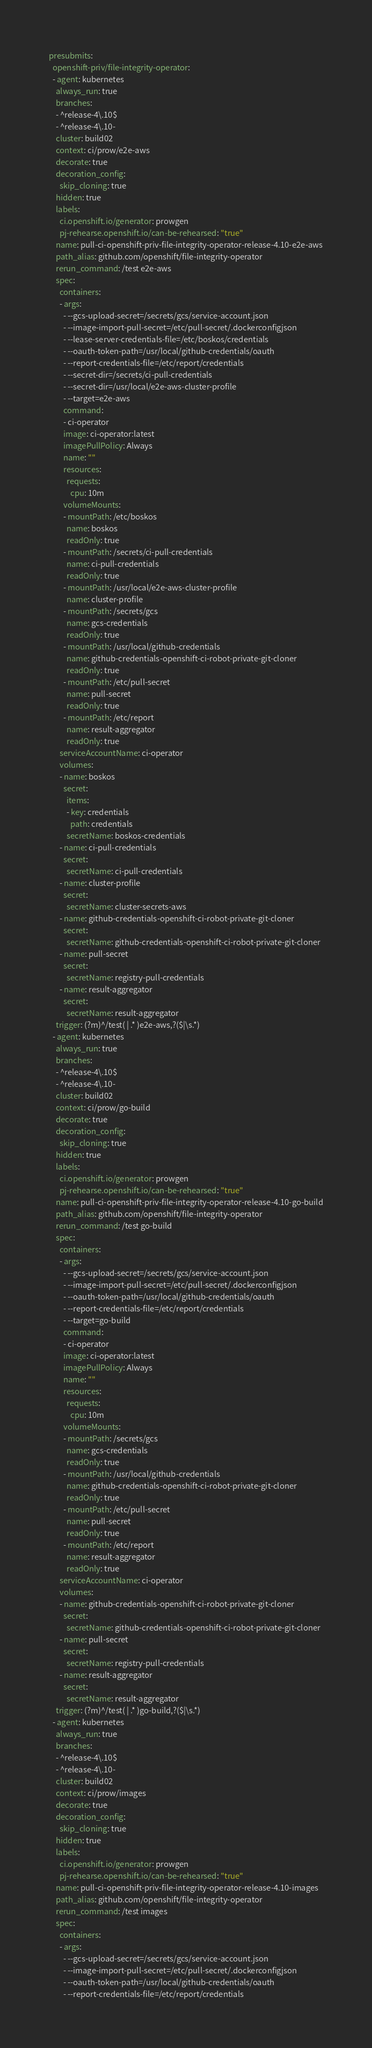Convert code to text. <code><loc_0><loc_0><loc_500><loc_500><_YAML_>presubmits:
  openshift-priv/file-integrity-operator:
  - agent: kubernetes
    always_run: true
    branches:
    - ^release-4\.10$
    - ^release-4\.10-
    cluster: build02
    context: ci/prow/e2e-aws
    decorate: true
    decoration_config:
      skip_cloning: true
    hidden: true
    labels:
      ci.openshift.io/generator: prowgen
      pj-rehearse.openshift.io/can-be-rehearsed: "true"
    name: pull-ci-openshift-priv-file-integrity-operator-release-4.10-e2e-aws
    path_alias: github.com/openshift/file-integrity-operator
    rerun_command: /test e2e-aws
    spec:
      containers:
      - args:
        - --gcs-upload-secret=/secrets/gcs/service-account.json
        - --image-import-pull-secret=/etc/pull-secret/.dockerconfigjson
        - --lease-server-credentials-file=/etc/boskos/credentials
        - --oauth-token-path=/usr/local/github-credentials/oauth
        - --report-credentials-file=/etc/report/credentials
        - --secret-dir=/secrets/ci-pull-credentials
        - --secret-dir=/usr/local/e2e-aws-cluster-profile
        - --target=e2e-aws
        command:
        - ci-operator
        image: ci-operator:latest
        imagePullPolicy: Always
        name: ""
        resources:
          requests:
            cpu: 10m
        volumeMounts:
        - mountPath: /etc/boskos
          name: boskos
          readOnly: true
        - mountPath: /secrets/ci-pull-credentials
          name: ci-pull-credentials
          readOnly: true
        - mountPath: /usr/local/e2e-aws-cluster-profile
          name: cluster-profile
        - mountPath: /secrets/gcs
          name: gcs-credentials
          readOnly: true
        - mountPath: /usr/local/github-credentials
          name: github-credentials-openshift-ci-robot-private-git-cloner
          readOnly: true
        - mountPath: /etc/pull-secret
          name: pull-secret
          readOnly: true
        - mountPath: /etc/report
          name: result-aggregator
          readOnly: true
      serviceAccountName: ci-operator
      volumes:
      - name: boskos
        secret:
          items:
          - key: credentials
            path: credentials
          secretName: boskos-credentials
      - name: ci-pull-credentials
        secret:
          secretName: ci-pull-credentials
      - name: cluster-profile
        secret:
          secretName: cluster-secrets-aws
      - name: github-credentials-openshift-ci-robot-private-git-cloner
        secret:
          secretName: github-credentials-openshift-ci-robot-private-git-cloner
      - name: pull-secret
        secret:
          secretName: registry-pull-credentials
      - name: result-aggregator
        secret:
          secretName: result-aggregator
    trigger: (?m)^/test( | .* )e2e-aws,?($|\s.*)
  - agent: kubernetes
    always_run: true
    branches:
    - ^release-4\.10$
    - ^release-4\.10-
    cluster: build02
    context: ci/prow/go-build
    decorate: true
    decoration_config:
      skip_cloning: true
    hidden: true
    labels:
      ci.openshift.io/generator: prowgen
      pj-rehearse.openshift.io/can-be-rehearsed: "true"
    name: pull-ci-openshift-priv-file-integrity-operator-release-4.10-go-build
    path_alias: github.com/openshift/file-integrity-operator
    rerun_command: /test go-build
    spec:
      containers:
      - args:
        - --gcs-upload-secret=/secrets/gcs/service-account.json
        - --image-import-pull-secret=/etc/pull-secret/.dockerconfigjson
        - --oauth-token-path=/usr/local/github-credentials/oauth
        - --report-credentials-file=/etc/report/credentials
        - --target=go-build
        command:
        - ci-operator
        image: ci-operator:latest
        imagePullPolicy: Always
        name: ""
        resources:
          requests:
            cpu: 10m
        volumeMounts:
        - mountPath: /secrets/gcs
          name: gcs-credentials
          readOnly: true
        - mountPath: /usr/local/github-credentials
          name: github-credentials-openshift-ci-robot-private-git-cloner
          readOnly: true
        - mountPath: /etc/pull-secret
          name: pull-secret
          readOnly: true
        - mountPath: /etc/report
          name: result-aggregator
          readOnly: true
      serviceAccountName: ci-operator
      volumes:
      - name: github-credentials-openshift-ci-robot-private-git-cloner
        secret:
          secretName: github-credentials-openshift-ci-robot-private-git-cloner
      - name: pull-secret
        secret:
          secretName: registry-pull-credentials
      - name: result-aggregator
        secret:
          secretName: result-aggregator
    trigger: (?m)^/test( | .* )go-build,?($|\s.*)
  - agent: kubernetes
    always_run: true
    branches:
    - ^release-4\.10$
    - ^release-4\.10-
    cluster: build02
    context: ci/prow/images
    decorate: true
    decoration_config:
      skip_cloning: true
    hidden: true
    labels:
      ci.openshift.io/generator: prowgen
      pj-rehearse.openshift.io/can-be-rehearsed: "true"
    name: pull-ci-openshift-priv-file-integrity-operator-release-4.10-images
    path_alias: github.com/openshift/file-integrity-operator
    rerun_command: /test images
    spec:
      containers:
      - args:
        - --gcs-upload-secret=/secrets/gcs/service-account.json
        - --image-import-pull-secret=/etc/pull-secret/.dockerconfigjson
        - --oauth-token-path=/usr/local/github-credentials/oauth
        - --report-credentials-file=/etc/report/credentials</code> 